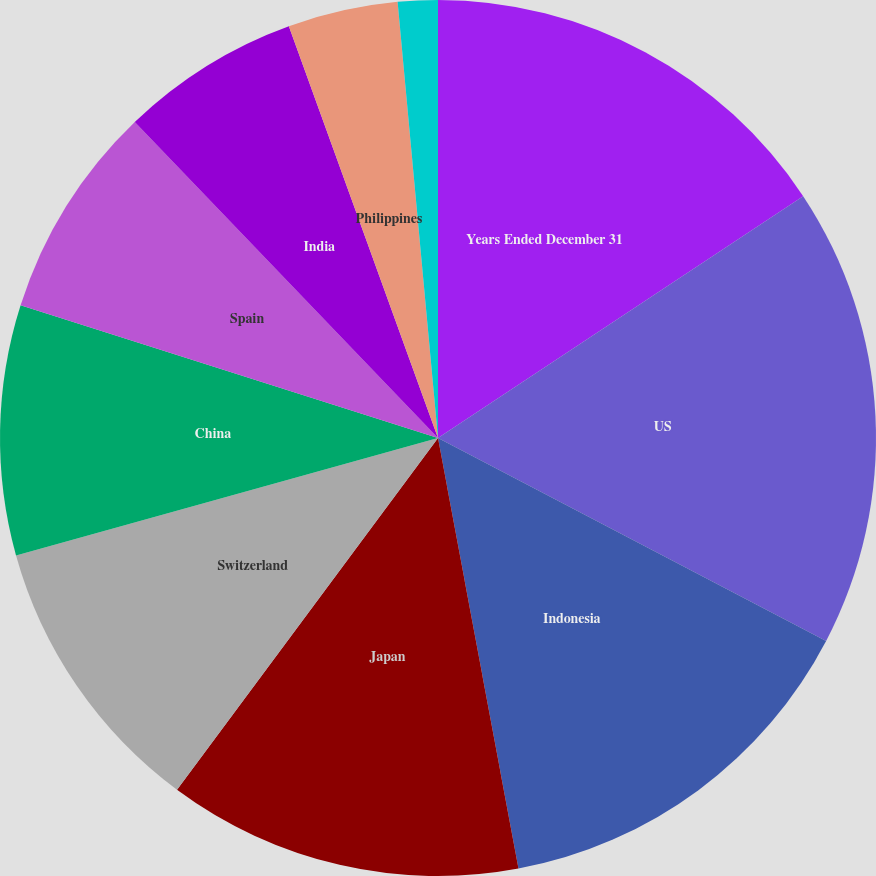Convert chart. <chart><loc_0><loc_0><loc_500><loc_500><pie_chart><fcel>Years Ended December 31<fcel>US<fcel>Indonesia<fcel>Japan<fcel>Switzerland<fcel>China<fcel>Spain<fcel>India<fcel>Philippines<fcel>Korea<nl><fcel>15.69%<fcel>16.98%<fcel>14.39%<fcel>13.1%<fcel>10.52%<fcel>9.22%<fcel>7.93%<fcel>6.64%<fcel>4.06%<fcel>1.47%<nl></chart> 